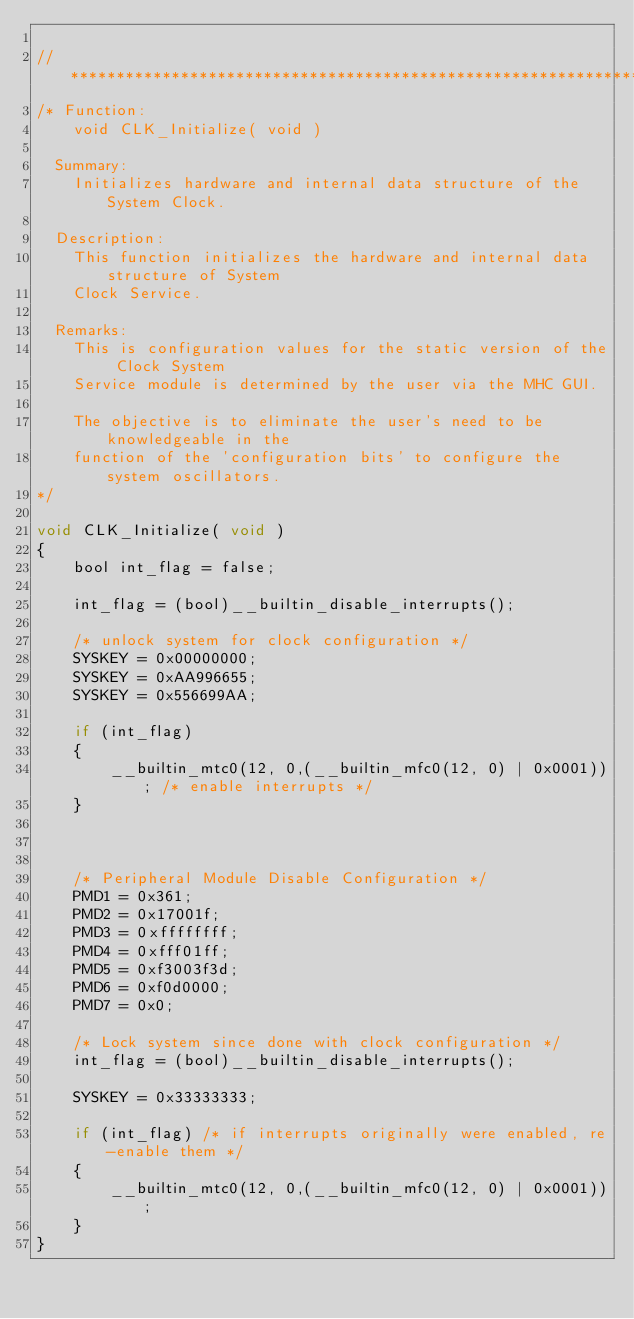<code> <loc_0><loc_0><loc_500><loc_500><_C_>
// *****************************************************************************
/* Function:
    void CLK_Initialize( void )

  Summary:
    Initializes hardware and internal data structure of the System Clock.

  Description:
    This function initializes the hardware and internal data structure of System
    Clock Service.

  Remarks:
    This is configuration values for the static version of the Clock System
    Service module is determined by the user via the MHC GUI.

    The objective is to eliminate the user's need to be knowledgeable in the
    function of the 'configuration bits' to configure the system oscillators.
*/

void CLK_Initialize( void )
{
    bool int_flag = false;

    int_flag = (bool)__builtin_disable_interrupts();

    /* unlock system for clock configuration */
    SYSKEY = 0x00000000;
    SYSKEY = 0xAA996655;
    SYSKEY = 0x556699AA;

    if (int_flag)
    {
        __builtin_mtc0(12, 0,(__builtin_mfc0(12, 0) | 0x0001)); /* enable interrupts */
    }

  

    /* Peripheral Module Disable Configuration */
    PMD1 = 0x361;
    PMD2 = 0x17001f;
    PMD3 = 0xffffffff;
    PMD4 = 0xfff01ff;
    PMD5 = 0xf3003f3d;
    PMD6 = 0xf0d0000;
    PMD7 = 0x0;

    /* Lock system since done with clock configuration */
    int_flag = (bool)__builtin_disable_interrupts();

    SYSKEY = 0x33333333;

    if (int_flag) /* if interrupts originally were enabled, re-enable them */
    {
        __builtin_mtc0(12, 0,(__builtin_mfc0(12, 0) | 0x0001));
    }
}
</code> 